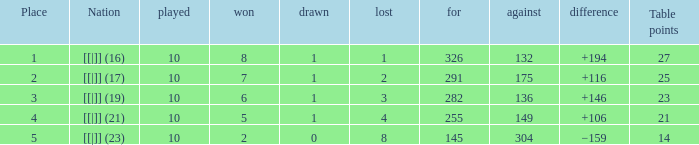 How many games had a deficit of 175?  1.0. 